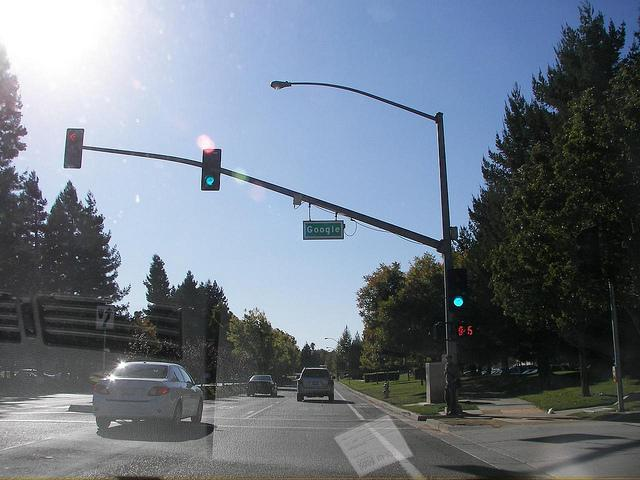What street is marked by the traffic light? Please explain your reasoning. google. There is a street sign on the light pole above the street. 